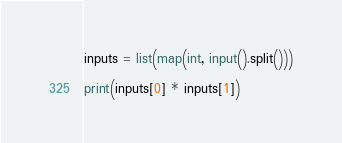Convert code to text. <code><loc_0><loc_0><loc_500><loc_500><_Python_>inputs = list(map(int, input().split()))

print(inputs[0] * inputs[1])</code> 